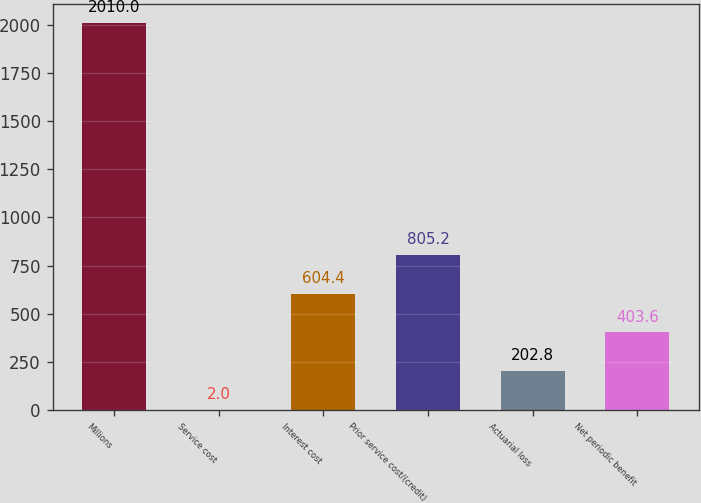Convert chart. <chart><loc_0><loc_0><loc_500><loc_500><bar_chart><fcel>Millions<fcel>Service cost<fcel>Interest cost<fcel>Prior service cost/(credit)<fcel>Actuarial loss<fcel>Net periodic benefit<nl><fcel>2010<fcel>2<fcel>604.4<fcel>805.2<fcel>202.8<fcel>403.6<nl></chart> 